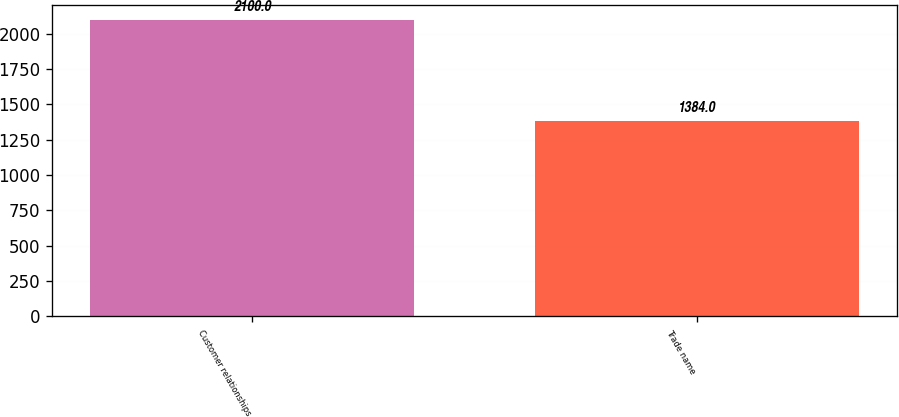<chart> <loc_0><loc_0><loc_500><loc_500><bar_chart><fcel>Customer relationships<fcel>Trade name<nl><fcel>2100<fcel>1384<nl></chart> 